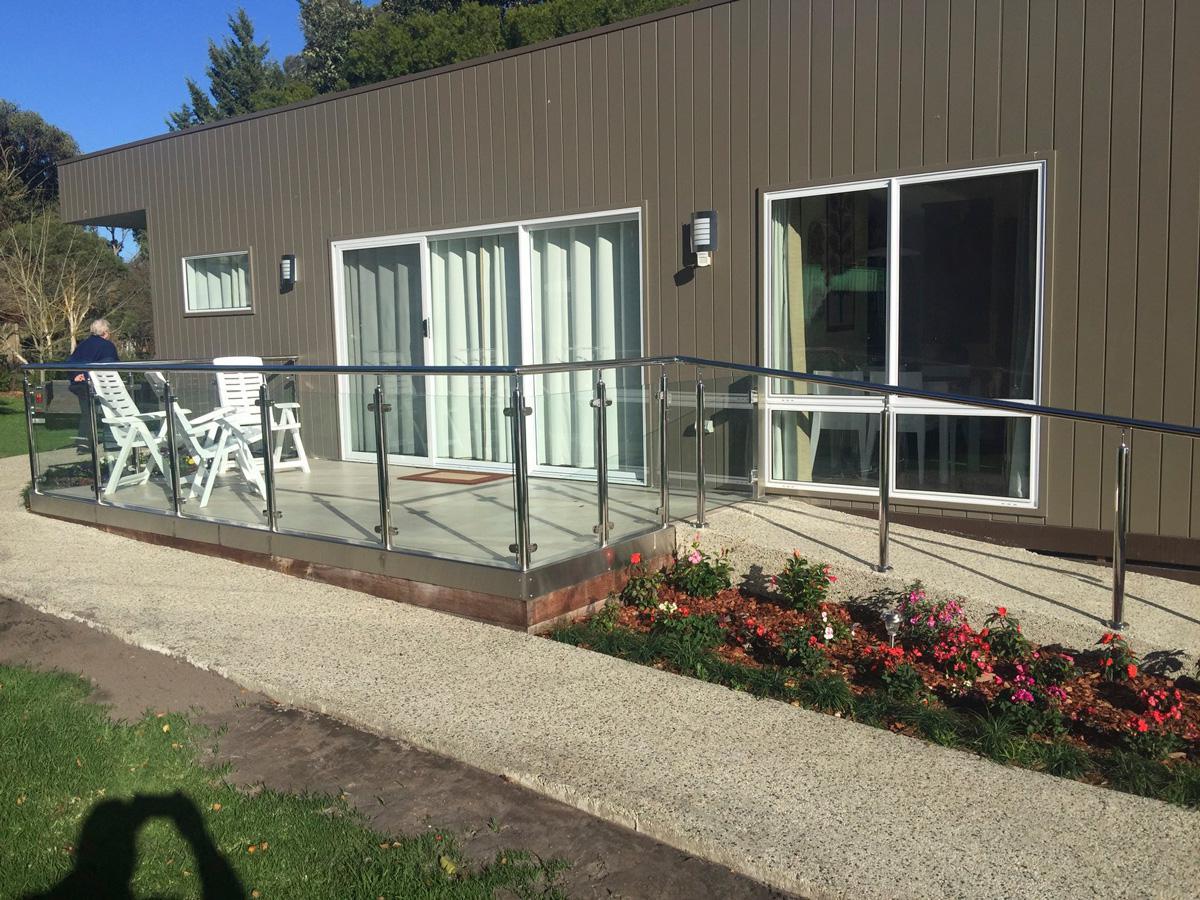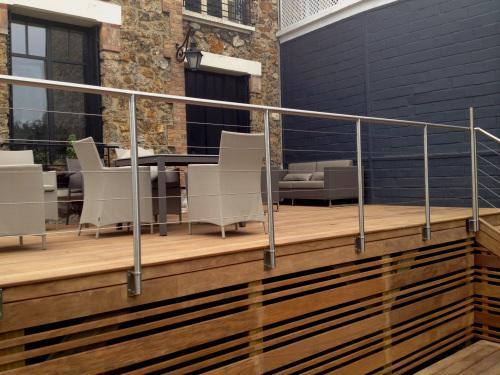The first image is the image on the left, the second image is the image on the right. Analyze the images presented: Is the assertion "The building in the image on the right is made of bricks." valid? Answer yes or no. Yes. The first image is the image on the left, the second image is the image on the right. Analyze the images presented: Is the assertion "One image shows a glass-paneled balcony with a corner on the left, a flat metal rail across the top, and no hinges connecting the balcony panels, and the other image shows a railing with horizontal bars." valid? Answer yes or no. No. 